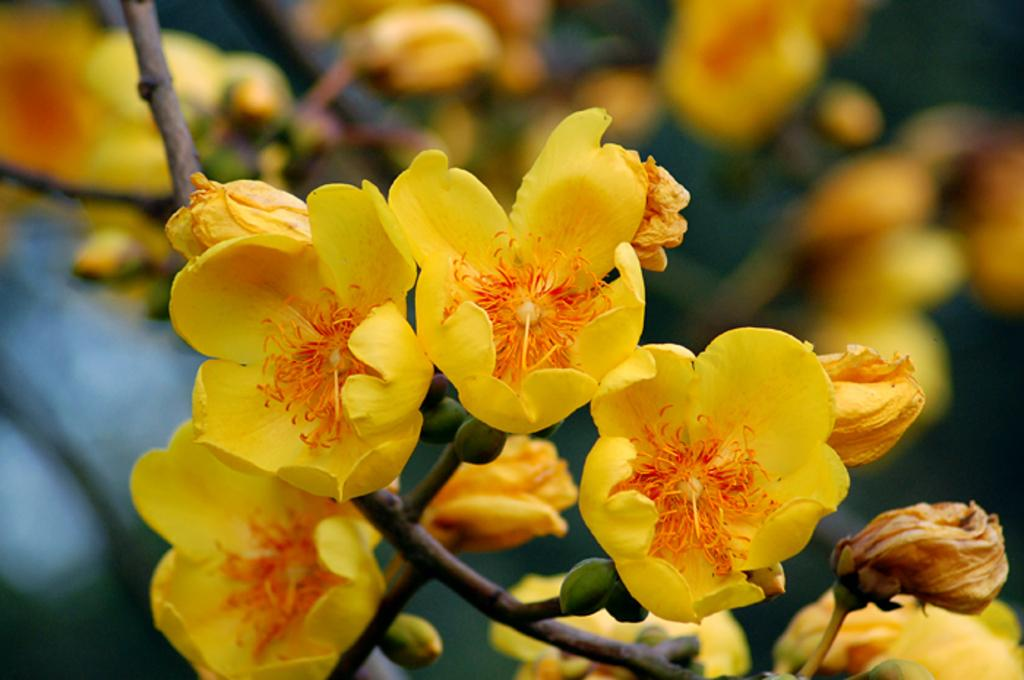What color are the flowers in the image? The flowers in the image are yellow. What is the color of the buds in the image? The buds in the image are green. What can be seen in the background of the image? In the background of the image, more flowers are visible. What type of pie is being sold at the flower shop in the image? There is no pie or flower shop present in the image; it only features flowers and buds. 